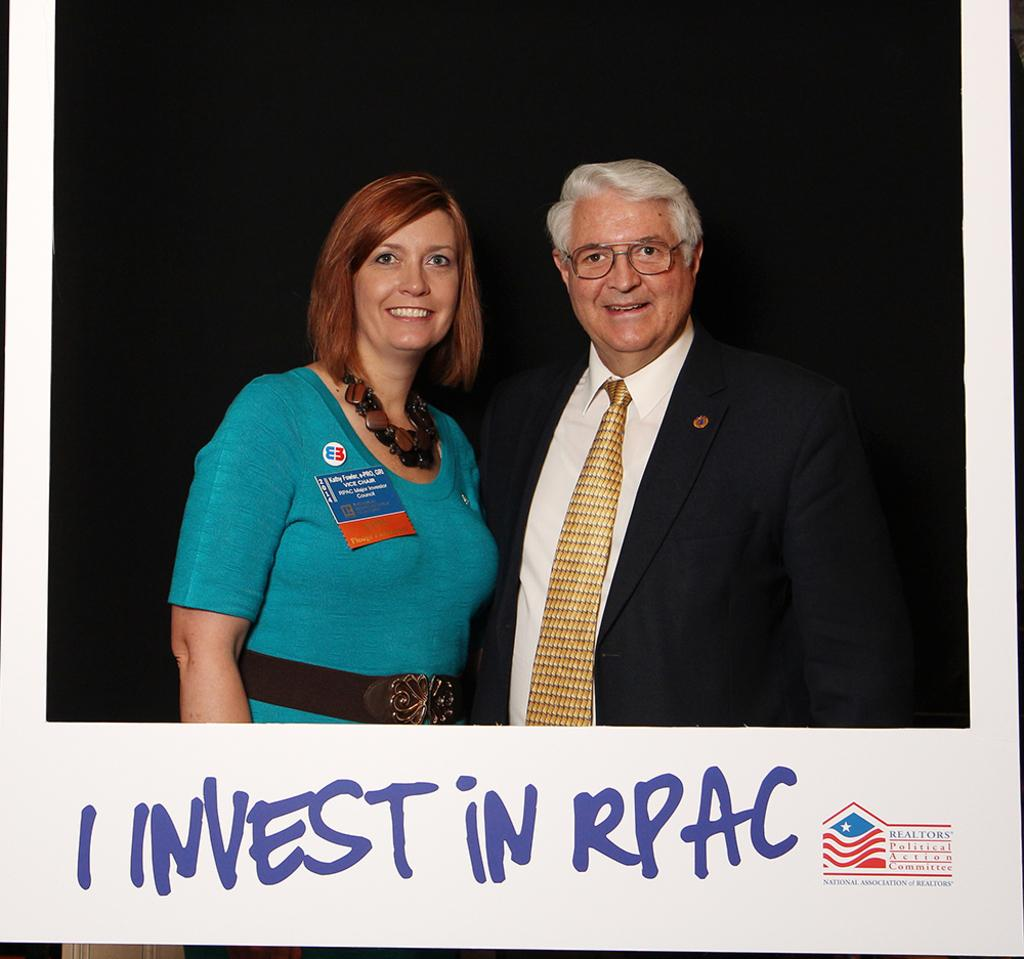<image>
Share a concise interpretation of the image provided. Two people posing for a photo with the words I Invest in RPAC below them. 